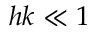Convert formula to latex. <formula><loc_0><loc_0><loc_500><loc_500>h k \ll 1</formula> 